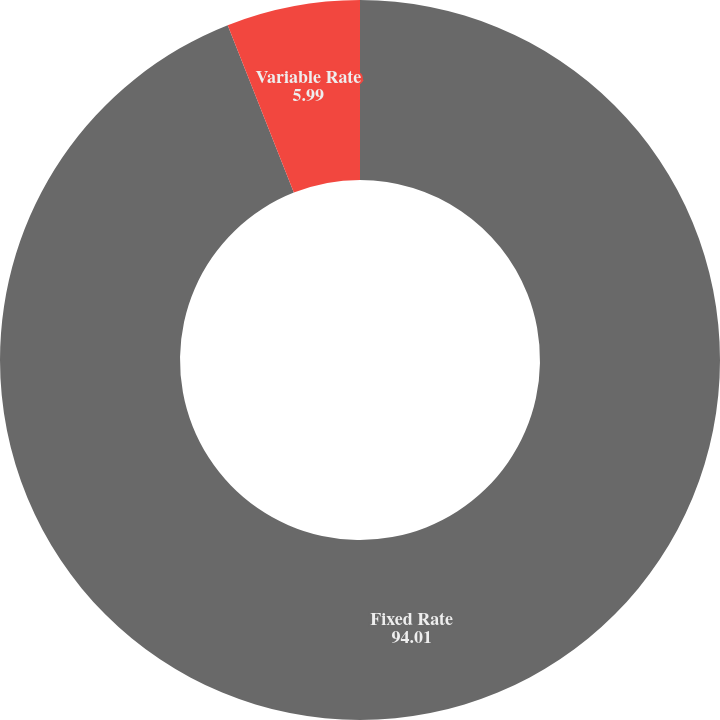Convert chart to OTSL. <chart><loc_0><loc_0><loc_500><loc_500><pie_chart><fcel>Fixed Rate<fcel>Variable Rate<nl><fcel>94.01%<fcel>5.99%<nl></chart> 